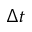Convert formula to latex. <formula><loc_0><loc_0><loc_500><loc_500>\Delta t</formula> 